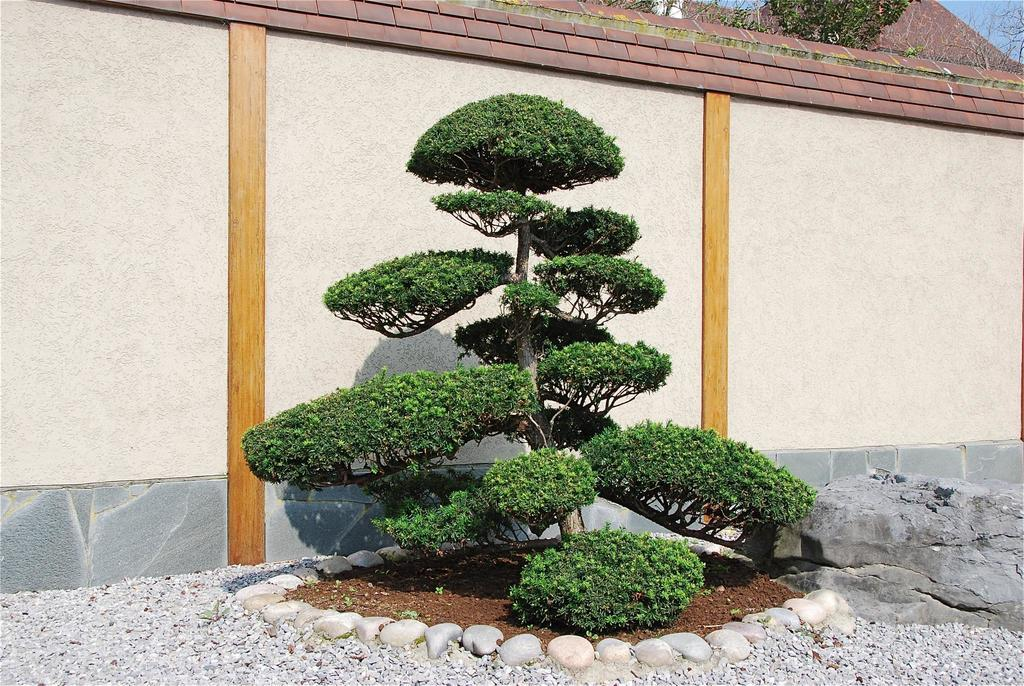What type of vegetation can be seen in the image? There are trees in the image. What structure is present in the image? There is a wall in the image. What material is visible at the bottom of the image? There are stones at the bottom of the image. What type of loss is depicted in the image? There is no depiction of loss in the image; it features trees, a wall, and stones. What part of a building can be seen in the image? There is no part of a building present in the image; it only features trees, a wall, and stones. 